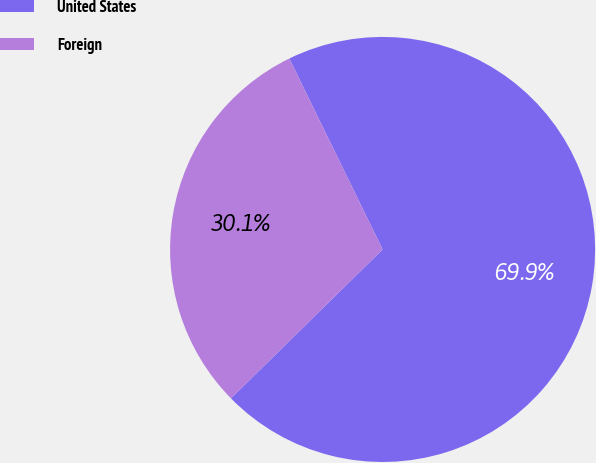<chart> <loc_0><loc_0><loc_500><loc_500><pie_chart><fcel>United States<fcel>Foreign<nl><fcel>69.88%<fcel>30.12%<nl></chart> 